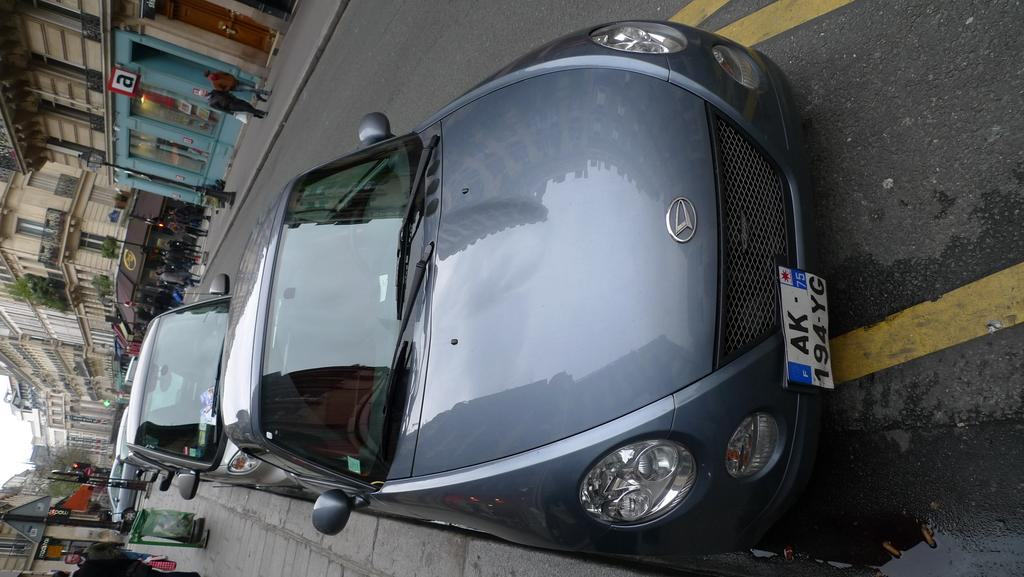<image>
Share a concise interpretation of the image provided. The blue car's front license plate reads AK-94-YG. 